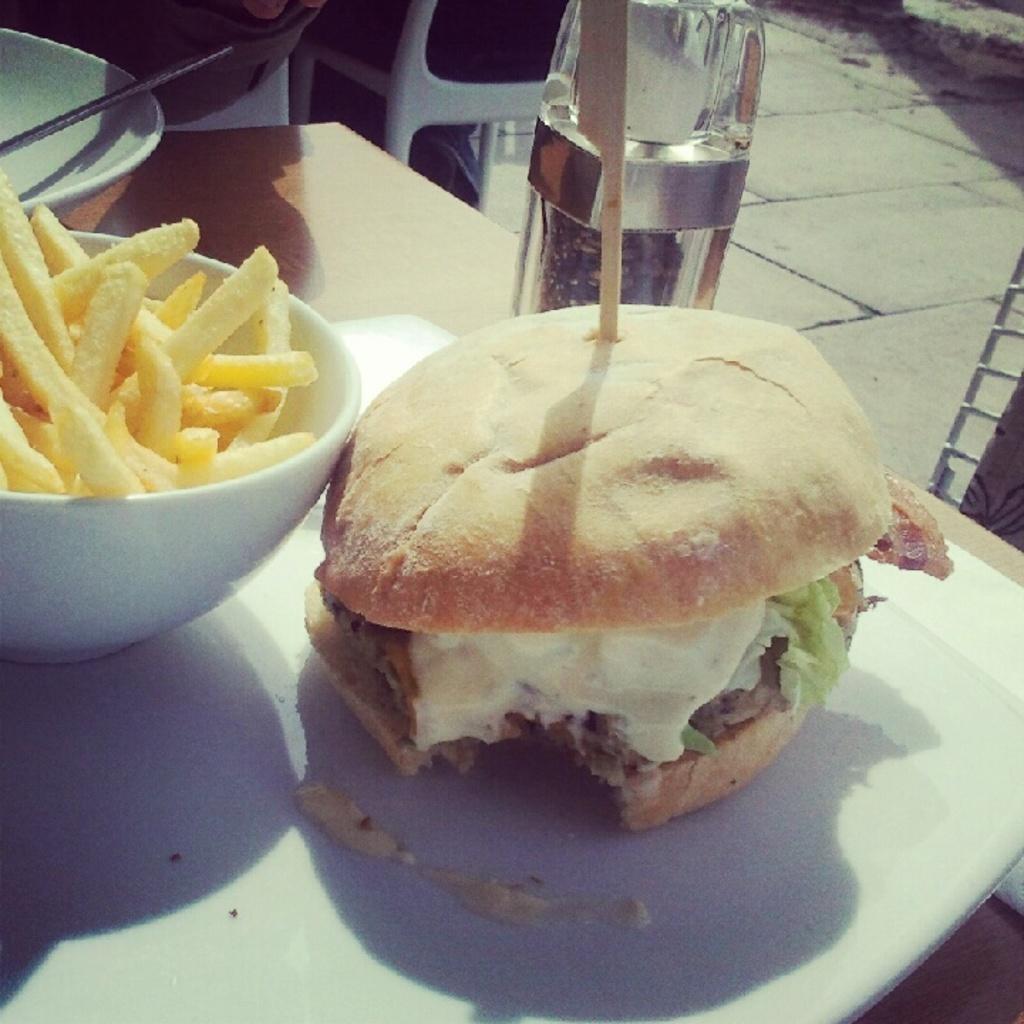Describe this image in one or two sentences. In this picture there is a burger and french fries in the bowl which is placed on the wooden table top. 